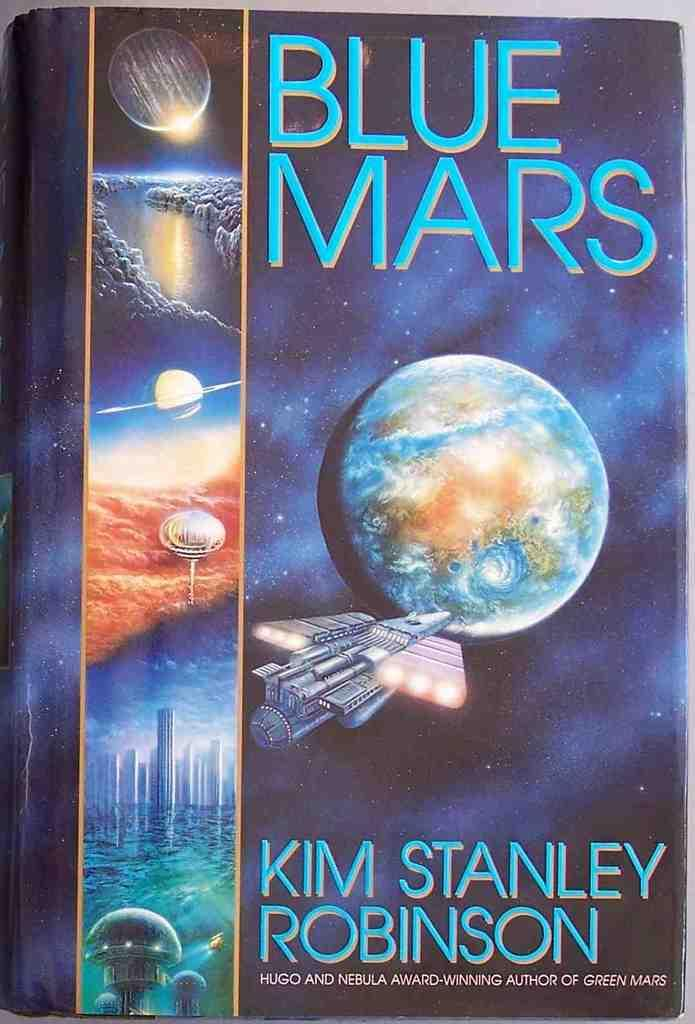<image>
Describe the image concisely. A book called Blue Mars shows a spaceship headed to Mars 